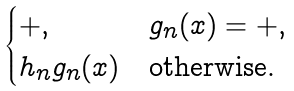<formula> <loc_0><loc_0><loc_500><loc_500>\begin{cases} + , & g _ { n } ( x ) = + , \\ h _ { n } g _ { n } ( x ) & \text {otherwise.} \end{cases}</formula> 